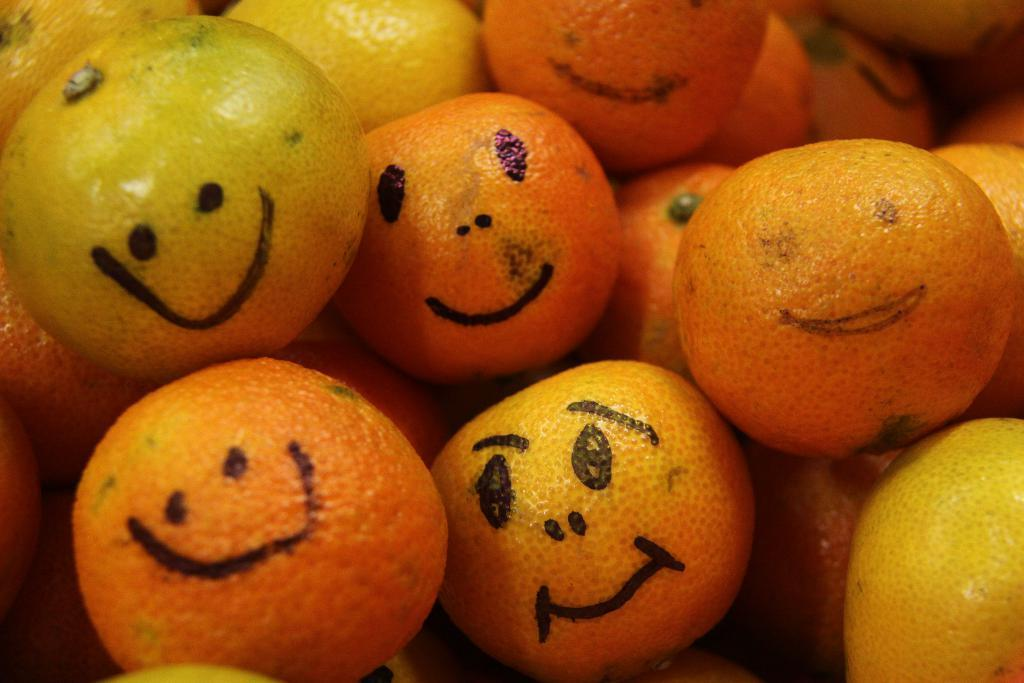What type of fruit is present in the image? There are oranges in the image. Are there any additional features on the oranges? Yes, there are drawings of smiley symbols on the oranges. Where is the hall located in the image? There is no hall present in the image; it features oranges with smiley symbols. What type of school is depicted in the image? There is no school present in the image; it features oranges with smiley symbols. 